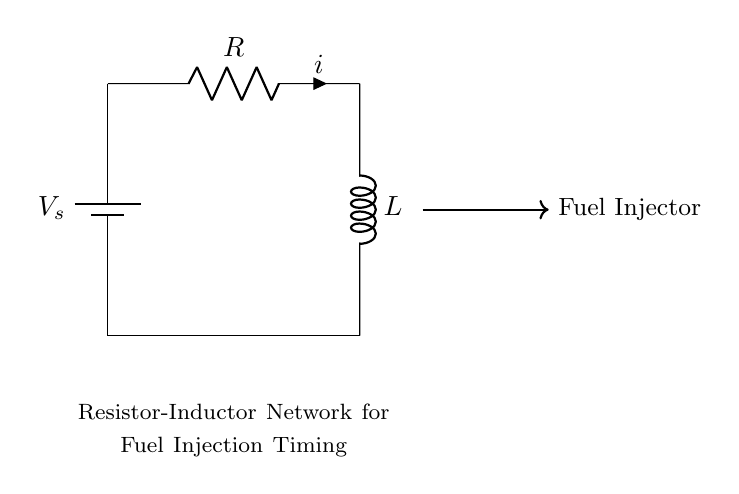What is the source voltage in this circuit? The source voltage is indicated by the label V_s placed next to the battery symbol in the circuit diagram.
Answer: V_s What is the component on the left side of the circuit? The left side of the circuit features a battery, which serves as the power source for the circuit.
Answer: Battery What type of circuit component is represented by R? R represents a resistor, which is a passive electrical component that resists the flow of current.
Answer: Resistor What role does the inductor L play in this circuit? The inductor L stores energy in the form of a magnetic field when current passes through it, which affects the timing of fuel delivery in the injection system.
Answer: Energy storage What is the relationship between the voltage across the resistor and the current i? According to Ohm's Law, the voltage across the resistor (V_R) is equal to the product of the current (i) and the resistance (R), expressed as V_R = i * R. This relationship impacts the overall behavior of the circuit.
Answer: Ohm's Law How does the combination of the resistor and inductor affect fuel delivery timing? The combination creates a time constant (τ = L/R), which determines how quickly the circuit responds to changes in current, affecting the timing of fuel delivery to the fuel injector.
Answer: Time constant What would happen if the resistance R is decreased? Decreasing resistance R would increase the current in the circuit, thereby decreasing the time constant and resulting in quicker response times for fuel delivery.
Answer: Quicker response 